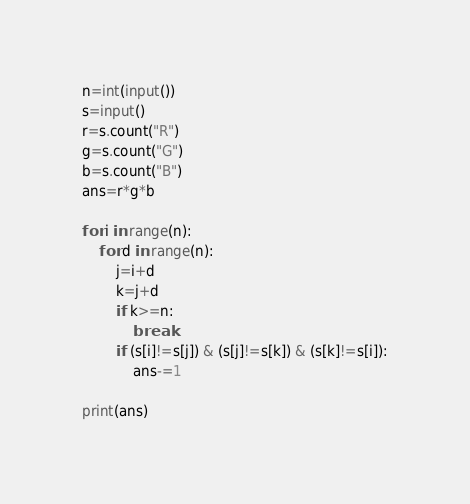<code> <loc_0><loc_0><loc_500><loc_500><_Python_>n=int(input())
s=input()
r=s.count("R")
g=s.count("G")
b=s.count("B")
ans=r*g*b

for i in range(n):
    for d in range(n):
        j=i+d
        k=j+d
        if k>=n:
            break
        if (s[i]!=s[j]) & (s[j]!=s[k]) & (s[k]!=s[i]):
            ans-=1

print(ans)</code> 